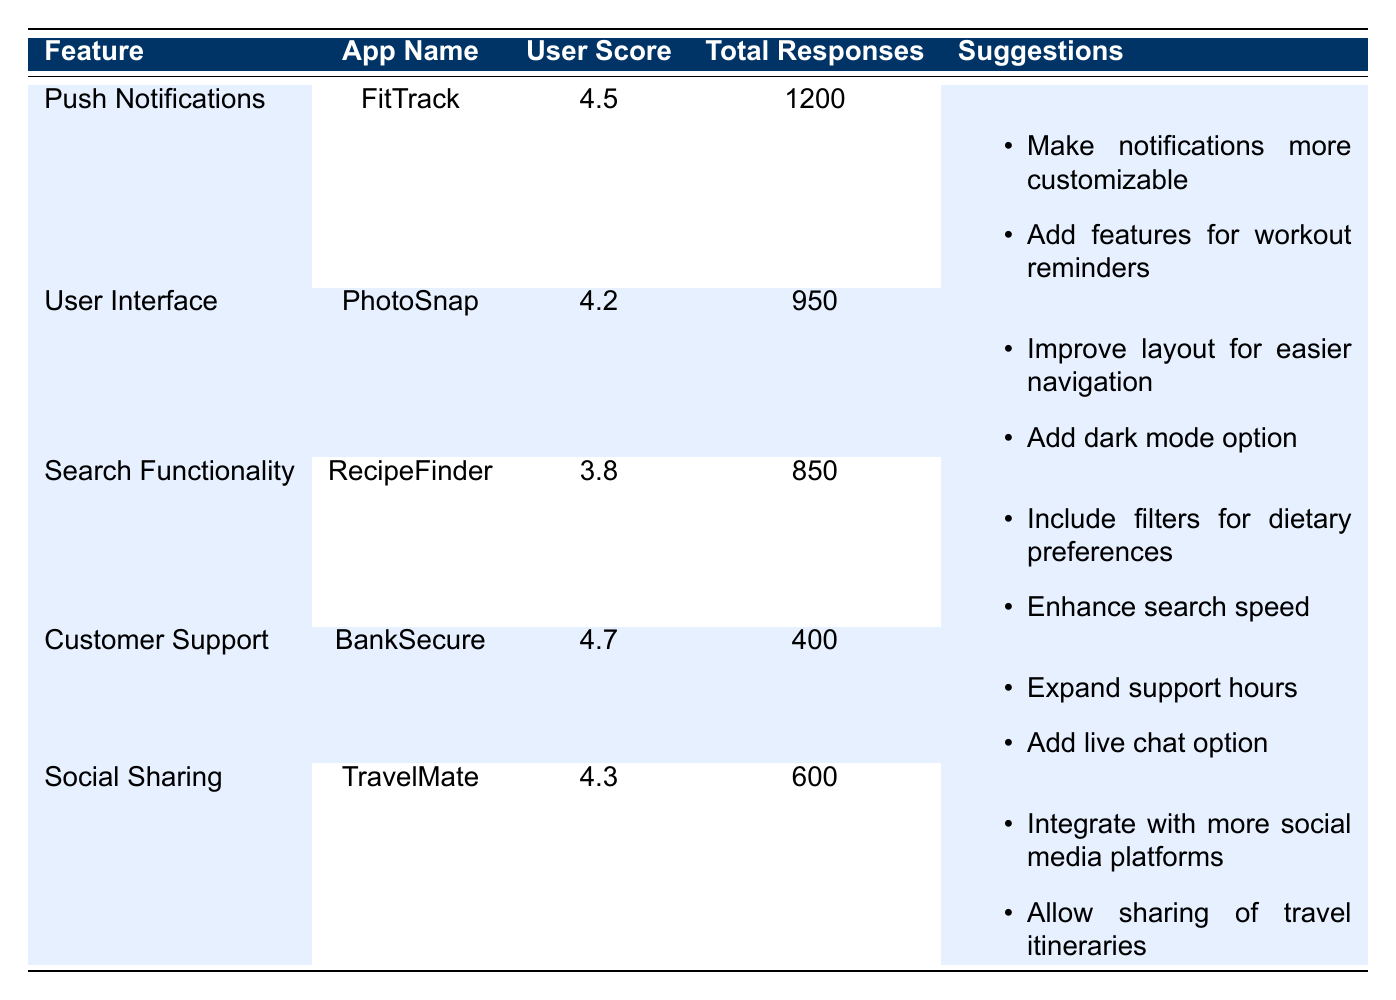What is the user feedback score for Push Notifications in the FitTrack app? The user feedback score for the feature "Push Notifications" in the app "FitTrack" is provided directly in the table. It indicates that users rated this feature 4.5 out of 5.
Answer: 4.5 Which app has the highest user feedback score? From the table, we can see all the user feedback scores. The highest score is 4.7, which belongs to the "Customer Support" feature of the app "BankSecure".
Answer: BankSecure What is the total number of responses for the User Interface feature? The table lists the total number of responses for each feature. For "User Interface" in "PhotoSnap", the total responses are 950.
Answer: 950 What is the average user feedback score for the features listed? To find the average, we add all the user feedback scores: (4.5 + 4.2 + 3.8 + 4.7 + 4.3) = 21.5. Dividing by the number of features (5) gives us an average of 21.5/5 = 4.3.
Answer: 4.3 Did any of the apps have suggestions related to adding more customization? From the table, the app "FitTrack" for "Push Notifications" suggested making notifications more customizable, which confirms that this app has related suggestions.
Answer: Yes How many total responses were given for features with a score less than 4.0? We check the scores in the table; only "Search Functionality" has a score of 3.8. The total responses for this feature is 850. As it's the only feature under 4.0, the total responses are 850.
Answer: 850 Is there a feature with more than 1000 responses? The table shows that "Push Notifications" in "FitTrack" has 1200 responses, which fulfills the condition.
Answer: Yes Which app has suggestions for improving navigation? The "User Interface" feature under the app "PhotoSnap" includes a suggestion to "Improve layout for easier navigation", confirming that this app has relevant suggestions.
Answer: PhotoSnap How many suggestions does the Customer Support feature have? The "Customer Support" feature in "BankSecure" lists two suggestions: "Expand support hours" and "Add live chat option". Therefore, it has a total of 2 suggestions.
Answer: 2 